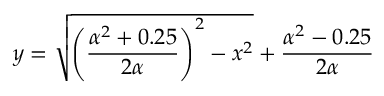Convert formula to latex. <formula><loc_0><loc_0><loc_500><loc_500>y = \sqrt { \left ( \frac { \alpha ^ { 2 } + 0 . 2 5 } { 2 \alpha } \right ) ^ { 2 } - x ^ { 2 } } + \frac { \alpha ^ { 2 } - 0 . 2 5 } { 2 \alpha }</formula> 